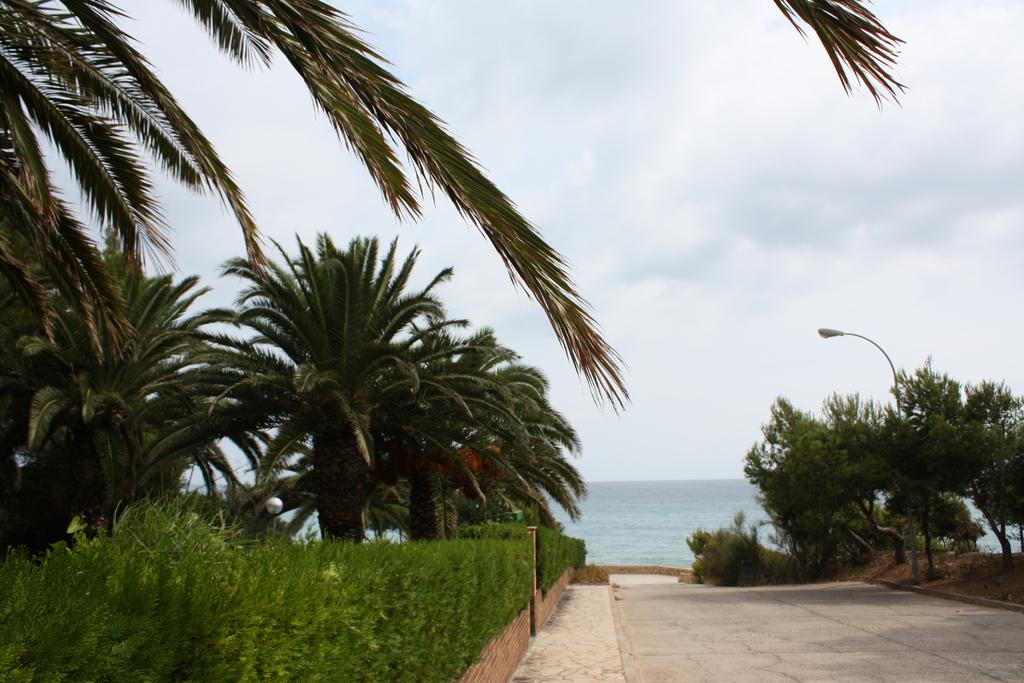What type of vegetation can be seen in the image? There are trees in the image. What structure is present in the image? There is a light pole in the image. What is visible at the top of the image? The sky is visible at the top of the image. What can be seen at the bottom of the image? There is water visible at the bottom of the image. What type of pathway is in the image? There is a road in the image. How much income does the trail generate in the image? There is no trail present in the image, so it is not possible to determine its income. 